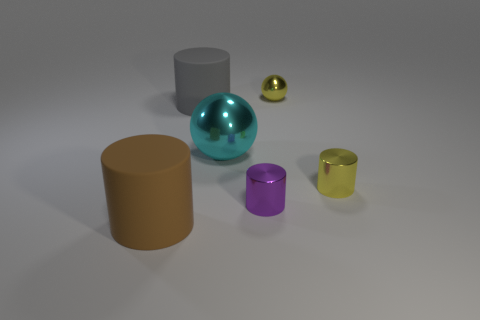Is the number of yellow metal cylinders less than the number of small brown metal spheres?
Keep it short and to the point. No. There is another big rubber thing that is the same shape as the gray rubber thing; what is its color?
Provide a short and direct response. Brown. There is a big object to the left of the cylinder behind the cyan metal sphere; are there any yellow cylinders on the right side of it?
Provide a short and direct response. Yes. Is the large brown object the same shape as the small purple shiny thing?
Offer a terse response. Yes. Are there fewer large metallic spheres that are to the left of the cyan ball than tiny things?
Your answer should be very brief. Yes. There is a matte thing that is behind the big cylinder that is in front of the large matte object that is behind the purple cylinder; what is its color?
Your answer should be very brief. Gray. What number of matte things are large purple balls or gray cylinders?
Your response must be concise. 1. Do the yellow shiny cylinder and the cyan shiny object have the same size?
Your response must be concise. No. Are there fewer yellow metallic spheres to the right of the small yellow shiny ball than shiny balls on the right side of the big cyan metallic ball?
Offer a terse response. Yes. The cyan sphere is what size?
Offer a terse response. Large. 